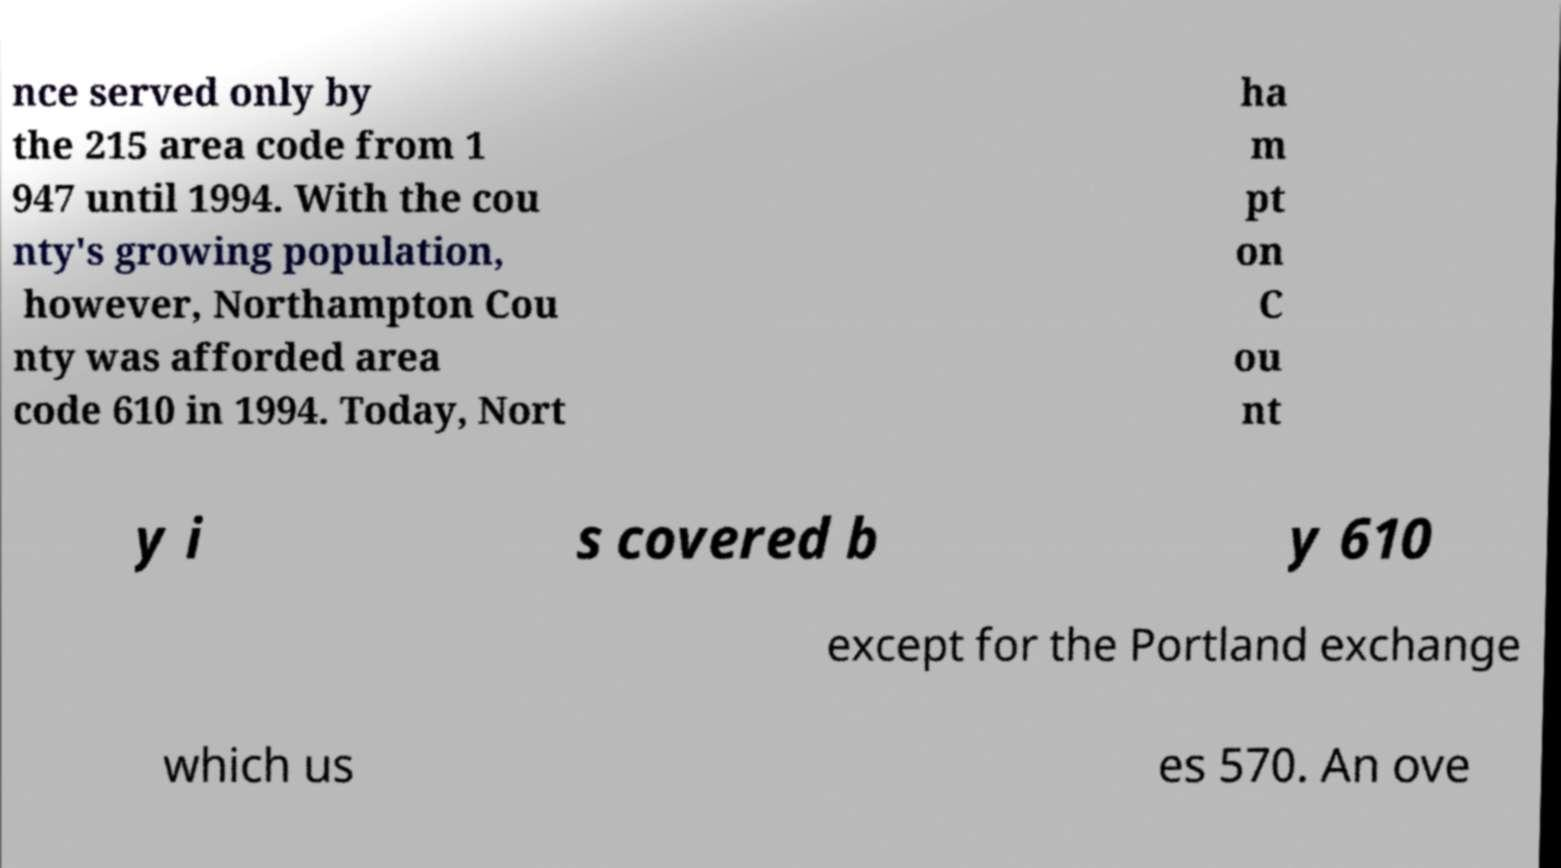For documentation purposes, I need the text within this image transcribed. Could you provide that? nce served only by the 215 area code from 1 947 until 1994. With the cou nty's growing population, however, Northampton Cou nty was afforded area code 610 in 1994. Today, Nort ha m pt on C ou nt y i s covered b y 610 except for the Portland exchange which us es 570. An ove 